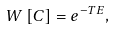<formula> <loc_0><loc_0><loc_500><loc_500>W \left [ C \right ] = e ^ { - T E } ,</formula> 